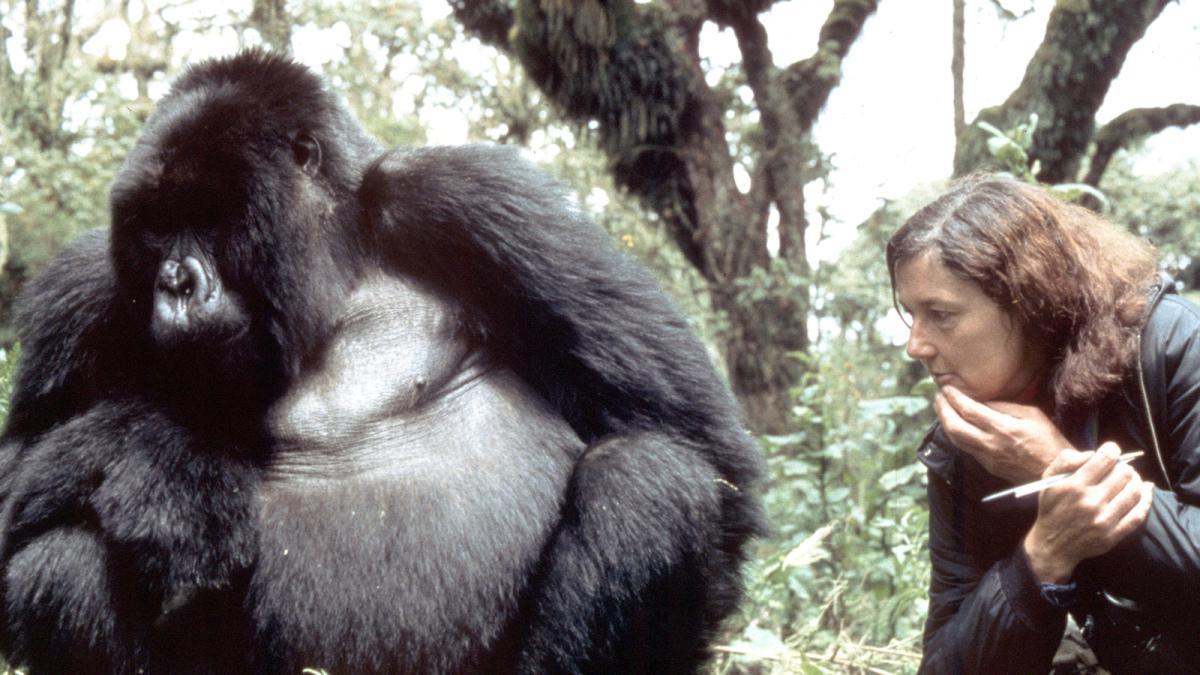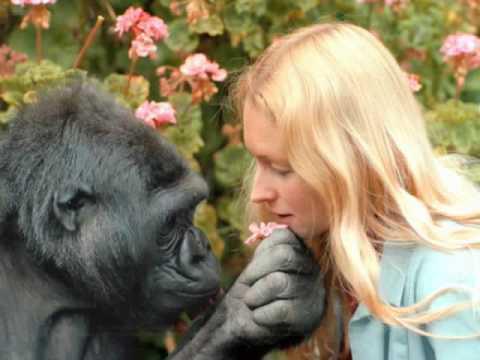The first image is the image on the left, the second image is the image on the right. Analyze the images presented: Is the assertion "The left and right image contains the same number gorillas on the left and people on the right." valid? Answer yes or no. Yes. The first image is the image on the left, the second image is the image on the right. Considering the images on both sides, is "Each image shows one person to the right of one gorilla, and the right image shows a gorilla face-to-face with and touching a person." valid? Answer yes or no. Yes. 